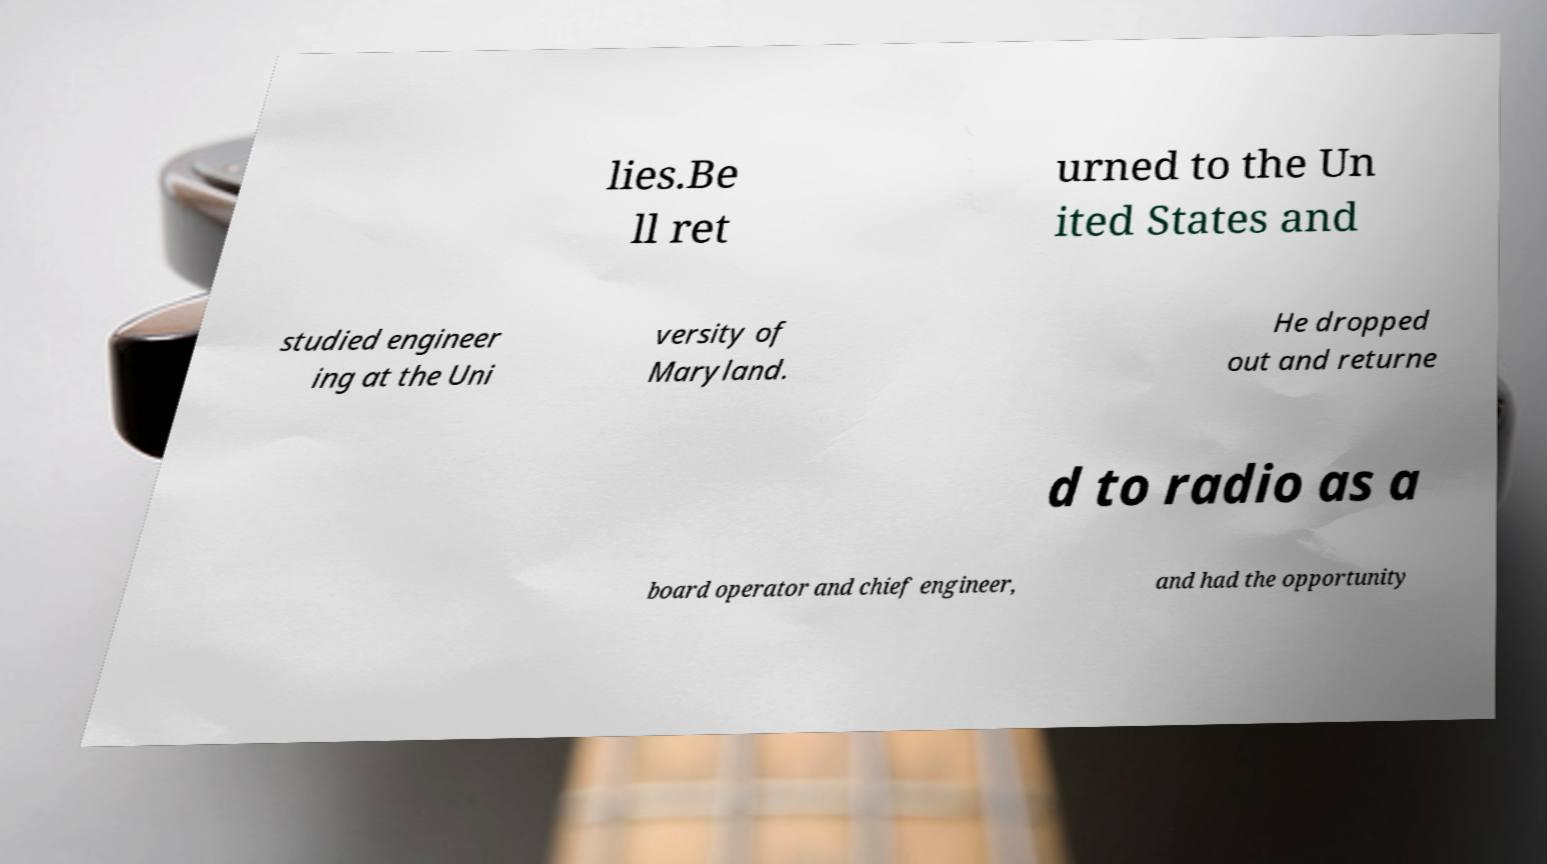Please identify and transcribe the text found in this image. lies.Be ll ret urned to the Un ited States and studied engineer ing at the Uni versity of Maryland. He dropped out and returne d to radio as a board operator and chief engineer, and had the opportunity 